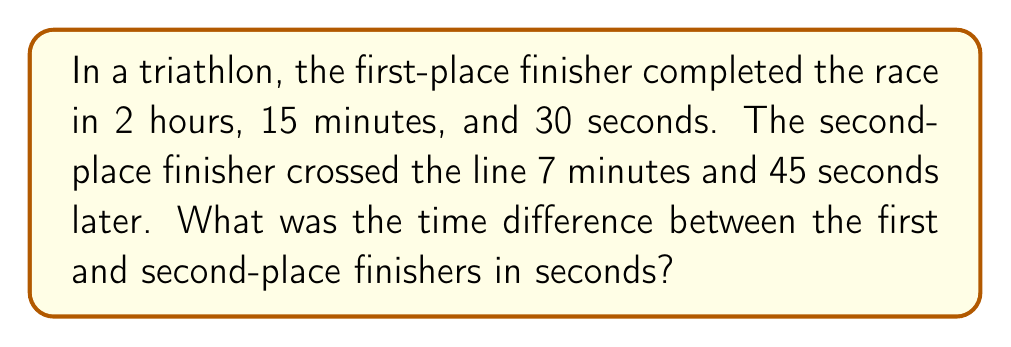Give your solution to this math problem. Let's approach this step-by-step:

1) First, we need to convert the first-place finisher's time to seconds:
   $2$ hours = $2 \times 60 \times 60 = 7200$ seconds
   $15$ minutes = $15 \times 60 = 900$ seconds
   $30$ seconds
   Total: $7200 + 900 + 30 = 8130$ seconds

2) Now, we need to convert the time difference to seconds:
   $7$ minutes = $7 \times 60 = 420$ seconds
   $45$ seconds
   Total difference: $420 + 45 = 465$ seconds

3) The question asks for the time difference, which we've calculated in step 2.

Therefore, the time difference between the first and second-place finishers is 465 seconds.
Answer: 465 seconds 